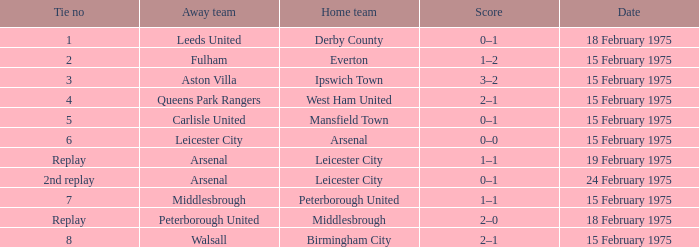Would you be able to parse every entry in this table? {'header': ['Tie no', 'Away team', 'Home team', 'Score', 'Date'], 'rows': [['1', 'Leeds United', 'Derby County', '0–1', '18 February 1975'], ['2', 'Fulham', 'Everton', '1–2', '15 February 1975'], ['3', 'Aston Villa', 'Ipswich Town', '3–2', '15 February 1975'], ['4', 'Queens Park Rangers', 'West Ham United', '2–1', '15 February 1975'], ['5', 'Carlisle United', 'Mansfield Town', '0–1', '15 February 1975'], ['6', 'Leicester City', 'Arsenal', '0–0', '15 February 1975'], ['Replay', 'Arsenal', 'Leicester City', '1–1', '19 February 1975'], ['2nd replay', 'Arsenal', 'Leicester City', '0–1', '24 February 1975'], ['7', 'Middlesbrough', 'Peterborough United', '1–1', '15 February 1975'], ['Replay', 'Peterborough United', 'Middlesbrough', '2–0', '18 February 1975'], ['8', 'Walsall', 'Birmingham City', '2–1', '15 February 1975']]} What was the specific date when leeds united played as the away team? 18 February 1975. 